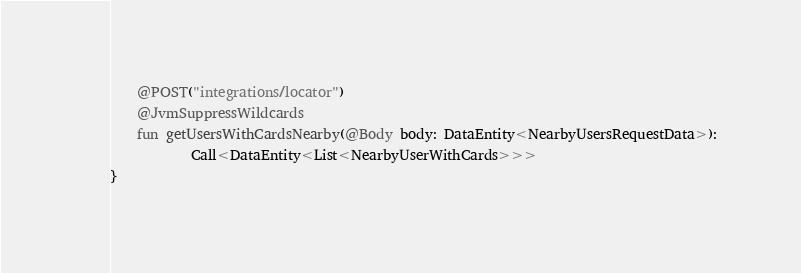Convert code to text. <code><loc_0><loc_0><loc_500><loc_500><_Kotlin_>    @POST("integrations/locator")
    @JvmSuppressWildcards
    fun getUsersWithCardsNearby(@Body body: DataEntity<NearbyUsersRequestData>):
            Call<DataEntity<List<NearbyUserWithCards>>>
}</code> 